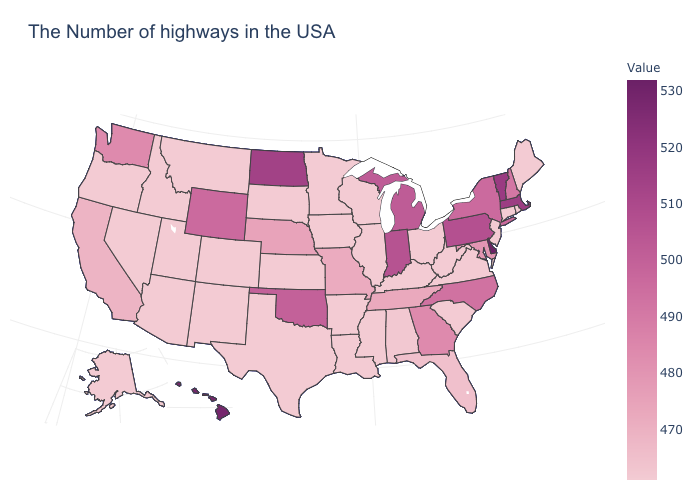Does New Hampshire have the highest value in the USA?
Be succinct. No. Among the states that border Kansas , which have the highest value?
Answer briefly. Oklahoma. Which states have the lowest value in the USA?
Keep it brief. Maine, Rhode Island, Connecticut, New Jersey, Virginia, South Carolina, West Virginia, Ohio, Kentucky, Wisconsin, Illinois, Mississippi, Louisiana, Arkansas, Minnesota, Iowa, Kansas, Texas, South Dakota, Colorado, New Mexico, Utah, Montana, Arizona, Idaho, Nevada, Oregon, Alaska. Does Hawaii have the highest value in the West?
Be succinct. Yes. 